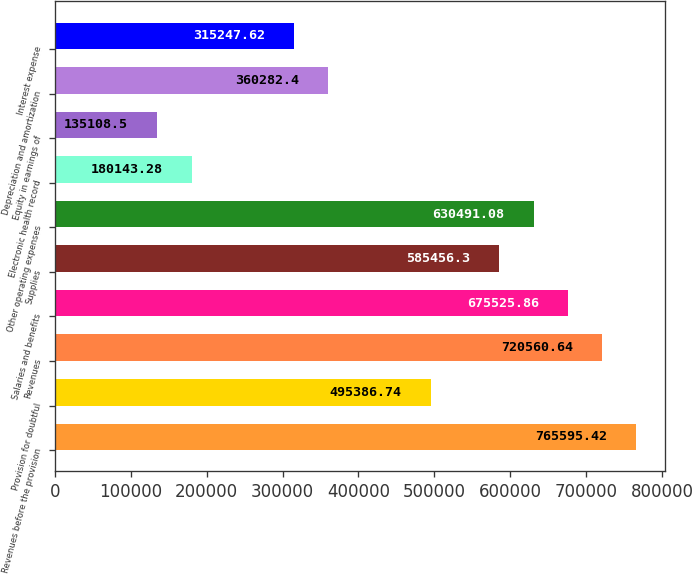<chart> <loc_0><loc_0><loc_500><loc_500><bar_chart><fcel>Revenues before the provision<fcel>Provision for doubtful<fcel>Revenues<fcel>Salaries and benefits<fcel>Supplies<fcel>Other operating expenses<fcel>Electronic health record<fcel>Equity in earnings of<fcel>Depreciation and amortization<fcel>Interest expense<nl><fcel>765595<fcel>495387<fcel>720561<fcel>675526<fcel>585456<fcel>630491<fcel>180143<fcel>135108<fcel>360282<fcel>315248<nl></chart> 